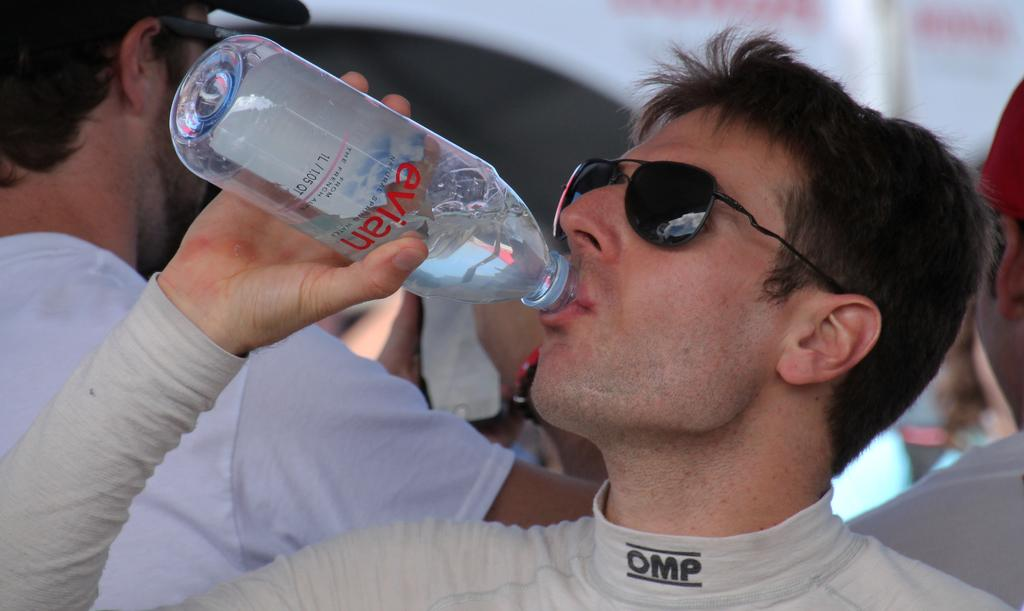What is the person wearing on their face in the image? The person is wearing goggles in the image. What is the person doing with the water bottle? The person is drinking water from a bottle in the image. What position is the person in? The person is standing in the image. What type of headwear is the person wearing? The person is wearing a cap in the image. What type of paste is the person applying to their toes in the image? There is no paste or reference to toes in the image; the person is wearing goggles, drinking water from a bottle, standing, and wearing a cap. 